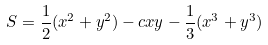Convert formula to latex. <formula><loc_0><loc_0><loc_500><loc_500>S = \frac { 1 } { 2 } ( x ^ { 2 } + y ^ { 2 } ) - c x y - \frac { 1 } { 3 } ( x ^ { 3 } + y ^ { 3 } )</formula> 